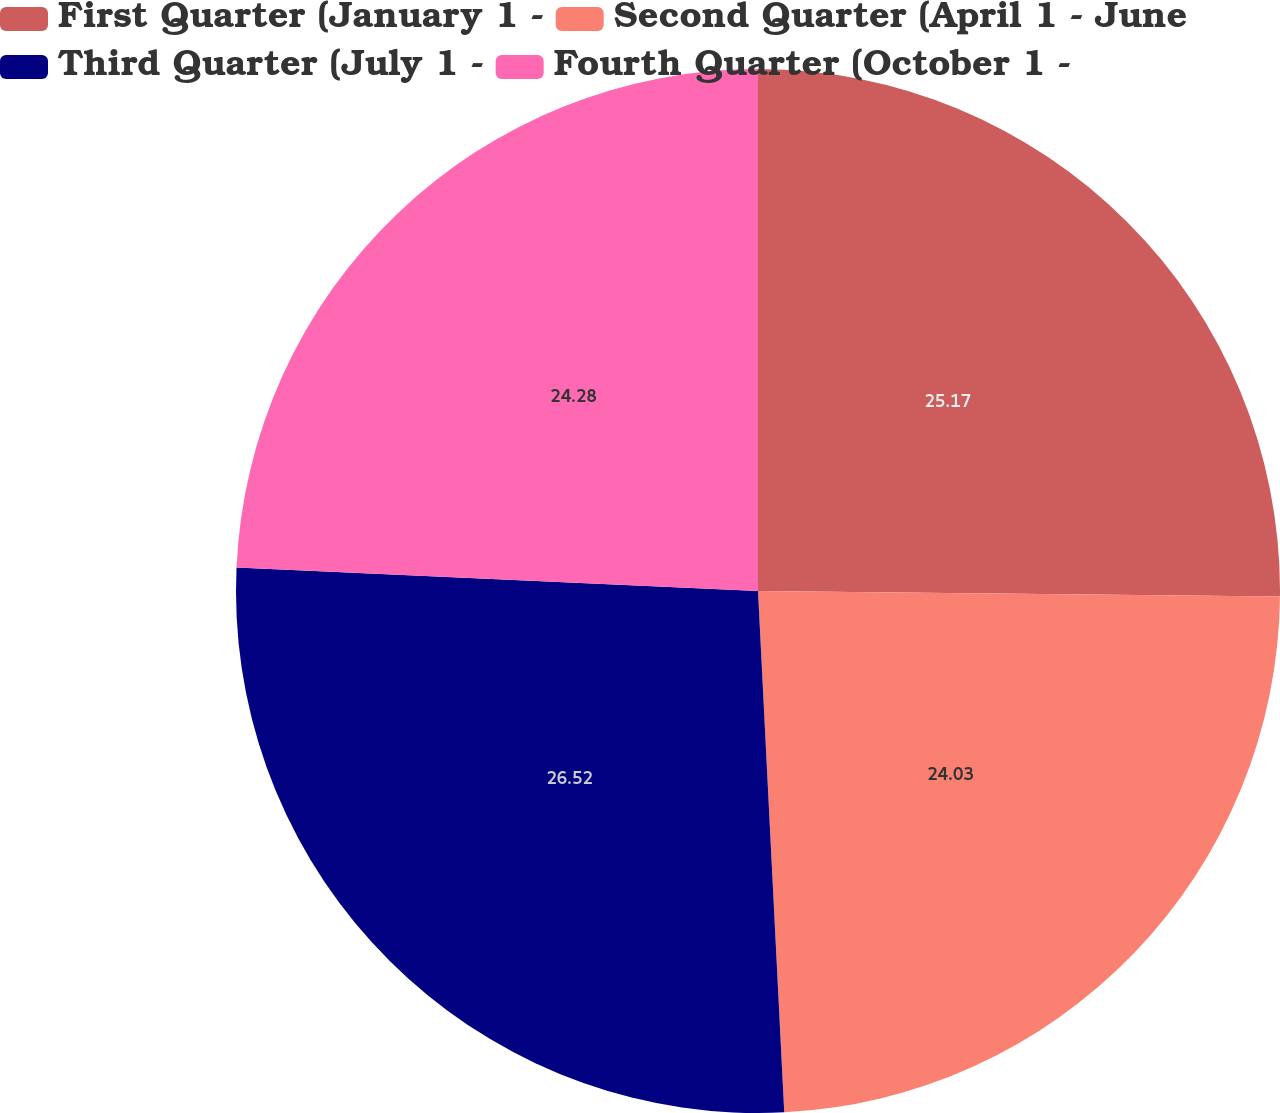Convert chart. <chart><loc_0><loc_0><loc_500><loc_500><pie_chart><fcel>First Quarter (January 1 -<fcel>Second Quarter (April 1 - June<fcel>Third Quarter (July 1 -<fcel>Fourth Quarter (October 1 -<nl><fcel>25.17%<fcel>24.03%<fcel>26.52%<fcel>24.28%<nl></chart> 